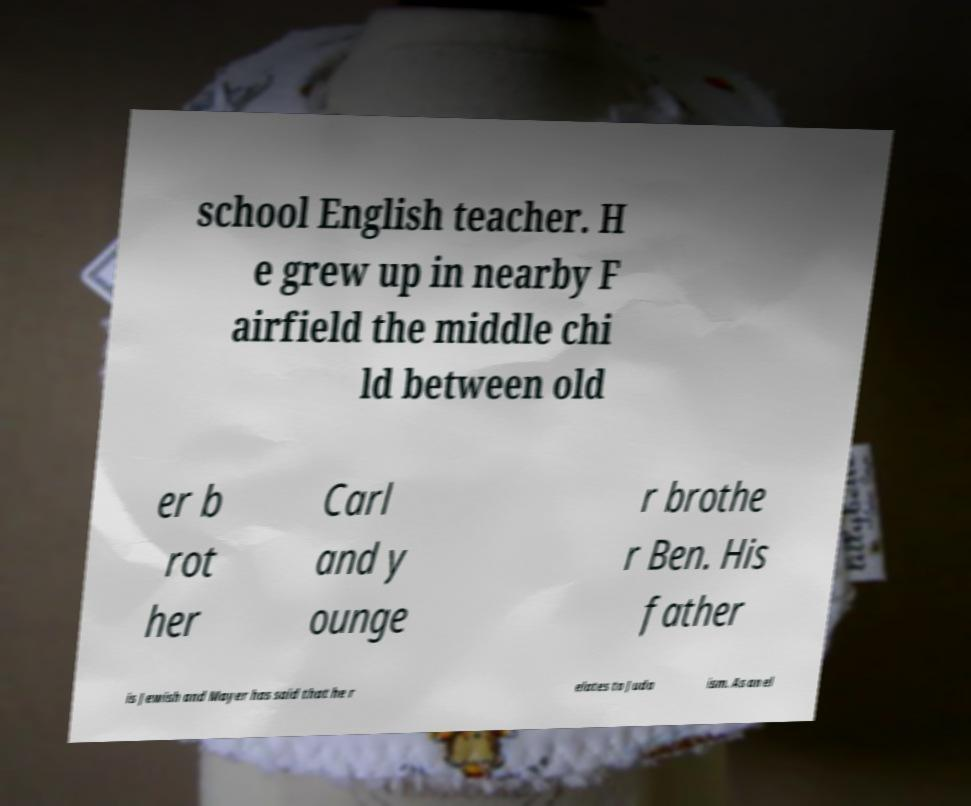I need the written content from this picture converted into text. Can you do that? school English teacher. H e grew up in nearby F airfield the middle chi ld between old er b rot her Carl and y ounge r brothe r Ben. His father is Jewish and Mayer has said that he r elates to Juda ism. As an el 